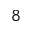<formula> <loc_0><loc_0><loc_500><loc_500>^ { 8 }</formula> 